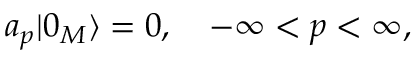Convert formula to latex. <formula><loc_0><loc_0><loc_500><loc_500>a _ { p } | 0 _ { M } \rangle = 0 , \quad - \infty < p < \infty ,</formula> 